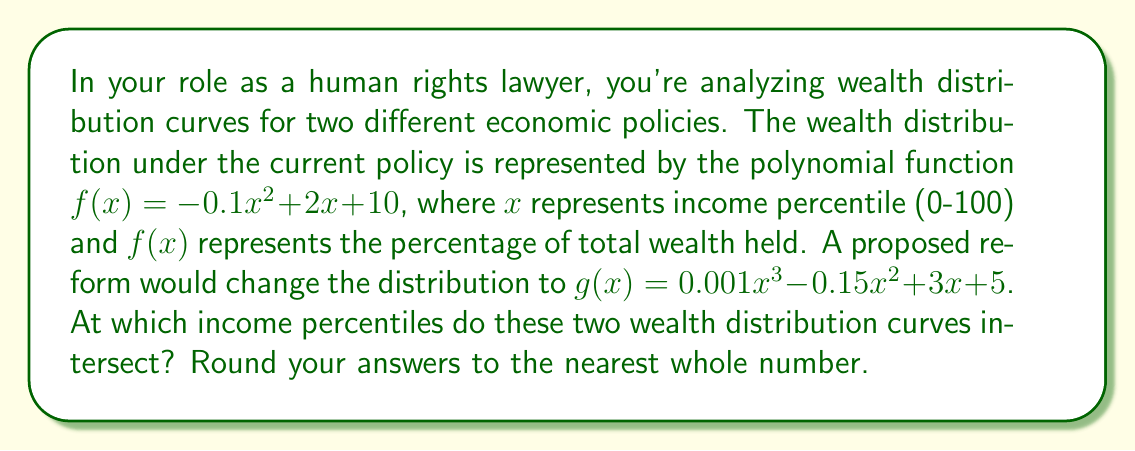Help me with this question. To find the intersection points of these two wealth distribution curves, we need to solve the equation:

$$f(x) = g(x)$$

Substituting the given functions:

$$-0.1x^2 + 2x + 10 = 0.001x^3 - 0.15x^2 + 3x + 5$$

Rearranging the equation:

$$0.001x^3 - 0.05x^2 + x - 5 = 0$$

This is a cubic equation that can be solved using various methods. One approach is to use a graphing calculator or computer algebra system to find the roots. However, we can also solve it analytically:

1) First, let's factor out the greatest common factor:

   $$0.001(x^3 - 50x^2 + 1000x - 5000) = 0$$

2) Using the rational root theorem, potential rational roots are factors of 5000: ±1, ±2, ±4, ±5, ±10, ±20, ±25, ±50, ±100, ±125, ±250, ±500, ±1000, ±2500, ±5000

3) Testing these values, we find that x = 25 is a root.

4) Factoring out (x - 25), we get:

   $$0.001(x - 25)(x^2 - 25x + 200) = 0$$

5) Using the quadratic formula on $x^2 - 25x + 200 = 0$, we get:

   $$x = \frac{25 \pm \sqrt{625 - 800}}{2} = \frac{25 \pm \sqrt{-175}}{2}$$

6) Since the other roots are complex, the only real solution in the domain [0, 100] is x = 25.

Therefore, the wealth distribution curves intersect at the 25th income percentile.
Answer: The wealth distribution curves intersect at the 25th income percentile. 